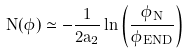<formula> <loc_0><loc_0><loc_500><loc_500>N ( \phi ) \simeq - \frac { 1 } { 2 a _ { 2 } } \ln \left ( \frac { \phi _ { N } } { \phi _ { E N D } } \right )</formula> 